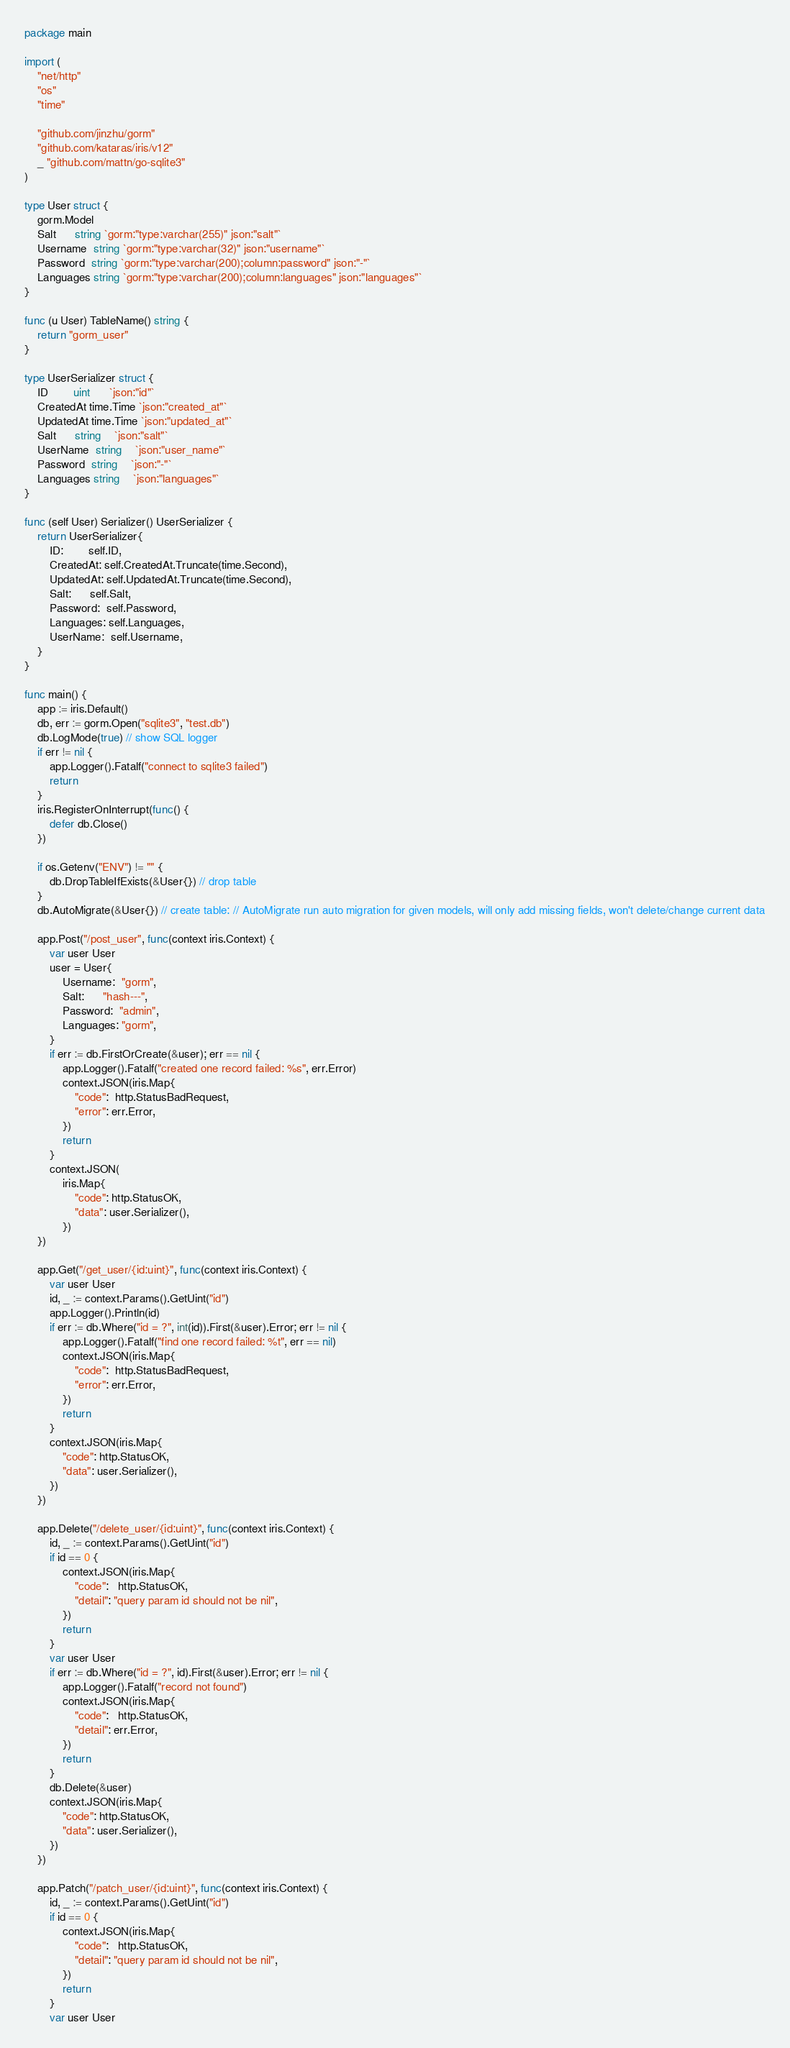<code> <loc_0><loc_0><loc_500><loc_500><_Go_>package main

import (
	"net/http"
	"os"
	"time"

	"github.com/jinzhu/gorm"
	"github.com/kataras/iris/v12"
	_ "github.com/mattn/go-sqlite3"
)

type User struct {
	gorm.Model
	Salt      string `gorm:"type:varchar(255)" json:"salt"`
	Username  string `gorm:"type:varchar(32)" json:"username"`
	Password  string `gorm:"type:varchar(200);column:password" json:"-"`
	Languages string `gorm:"type:varchar(200);column:languages" json:"languages"`
}

func (u User) TableName() string {
	return "gorm_user"
}

type UserSerializer struct {
	ID        uint      `json:"id"`
	CreatedAt time.Time `json:"created_at"`
	UpdatedAt time.Time `json:"updated_at"`
	Salt      string    `json:"salt"`
	UserName  string    `json:"user_name"`
	Password  string    `json:"-"`
	Languages string    `json:"languages"`
}

func (self User) Serializer() UserSerializer {
	return UserSerializer{
		ID:        self.ID,
		CreatedAt: self.CreatedAt.Truncate(time.Second),
		UpdatedAt: self.UpdatedAt.Truncate(time.Second),
		Salt:      self.Salt,
		Password:  self.Password,
		Languages: self.Languages,
		UserName:  self.Username,
	}
}

func main() {
	app := iris.Default()
	db, err := gorm.Open("sqlite3", "test.db")
	db.LogMode(true) // show SQL logger
	if err != nil {
		app.Logger().Fatalf("connect to sqlite3 failed")
		return
	}
	iris.RegisterOnInterrupt(func() {
		defer db.Close()
	})

	if os.Getenv("ENV") != "" {
		db.DropTableIfExists(&User{}) // drop table
	}
	db.AutoMigrate(&User{}) // create table: // AutoMigrate run auto migration for given models, will only add missing fields, won't delete/change current data

	app.Post("/post_user", func(context iris.Context) {
		var user User
		user = User{
			Username:  "gorm",
			Salt:      "hash---",
			Password:  "admin",
			Languages: "gorm",
		}
		if err := db.FirstOrCreate(&user); err == nil {
			app.Logger().Fatalf("created one record failed: %s", err.Error)
			context.JSON(iris.Map{
				"code":  http.StatusBadRequest,
				"error": err.Error,
			})
			return
		}
		context.JSON(
			iris.Map{
				"code": http.StatusOK,
				"data": user.Serializer(),
			})
	})

	app.Get("/get_user/{id:uint}", func(context iris.Context) {
		var user User
		id, _ := context.Params().GetUint("id")
		app.Logger().Println(id)
		if err := db.Where("id = ?", int(id)).First(&user).Error; err != nil {
			app.Logger().Fatalf("find one record failed: %t", err == nil)
			context.JSON(iris.Map{
				"code":  http.StatusBadRequest,
				"error": err.Error,
			})
			return
		}
		context.JSON(iris.Map{
			"code": http.StatusOK,
			"data": user.Serializer(),
		})
	})

	app.Delete("/delete_user/{id:uint}", func(context iris.Context) {
		id, _ := context.Params().GetUint("id")
		if id == 0 {
			context.JSON(iris.Map{
				"code":   http.StatusOK,
				"detail": "query param id should not be nil",
			})
			return
		}
		var user User
		if err := db.Where("id = ?", id).First(&user).Error; err != nil {
			app.Logger().Fatalf("record not found")
			context.JSON(iris.Map{
				"code":   http.StatusOK,
				"detail": err.Error,
			})
			return
		}
		db.Delete(&user)
		context.JSON(iris.Map{
			"code": http.StatusOK,
			"data": user.Serializer(),
		})
	})

	app.Patch("/patch_user/{id:uint}", func(context iris.Context) {
		id, _ := context.Params().GetUint("id")
		if id == 0 {
			context.JSON(iris.Map{
				"code":   http.StatusOK,
				"detail": "query param id should not be nil",
			})
			return
		}
		var user User</code> 